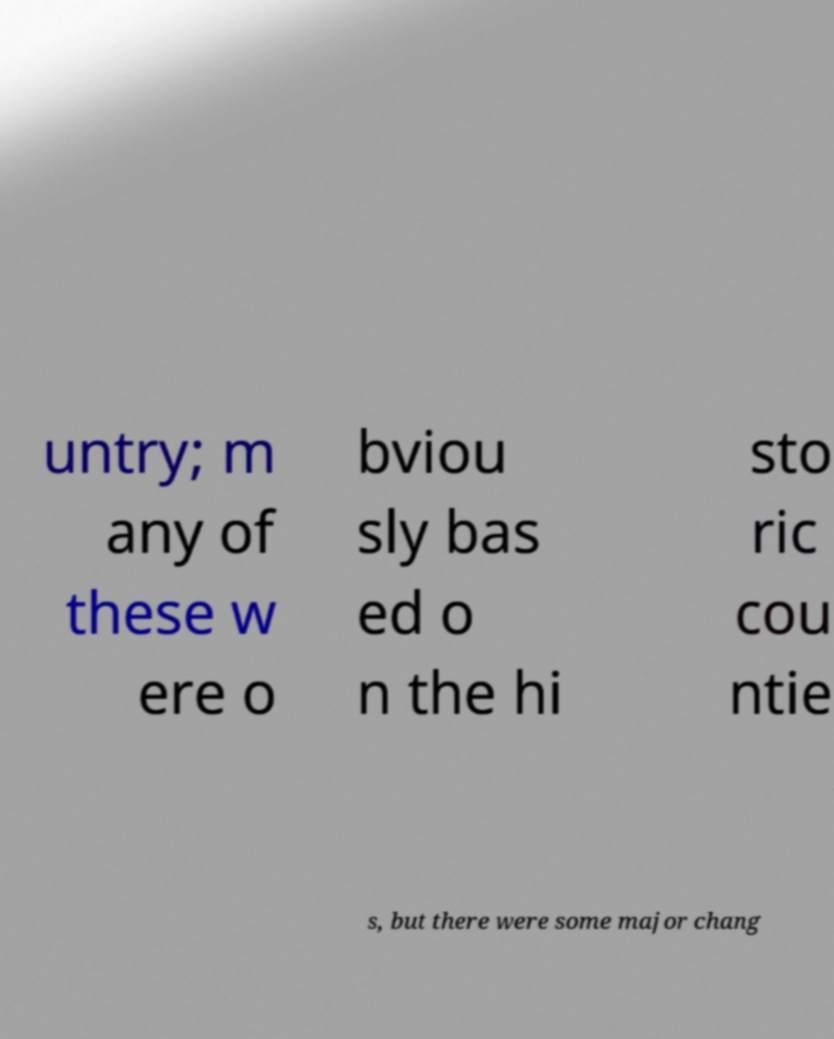For documentation purposes, I need the text within this image transcribed. Could you provide that? untry; m any of these w ere o bviou sly bas ed o n the hi sto ric cou ntie s, but there were some major chang 